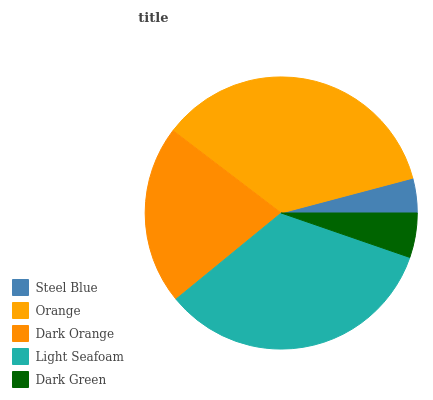Is Steel Blue the minimum?
Answer yes or no. Yes. Is Orange the maximum?
Answer yes or no. Yes. Is Dark Orange the minimum?
Answer yes or no. No. Is Dark Orange the maximum?
Answer yes or no. No. Is Orange greater than Dark Orange?
Answer yes or no. Yes. Is Dark Orange less than Orange?
Answer yes or no. Yes. Is Dark Orange greater than Orange?
Answer yes or no. No. Is Orange less than Dark Orange?
Answer yes or no. No. Is Dark Orange the high median?
Answer yes or no. Yes. Is Dark Orange the low median?
Answer yes or no. Yes. Is Light Seafoam the high median?
Answer yes or no. No. Is Orange the low median?
Answer yes or no. No. 